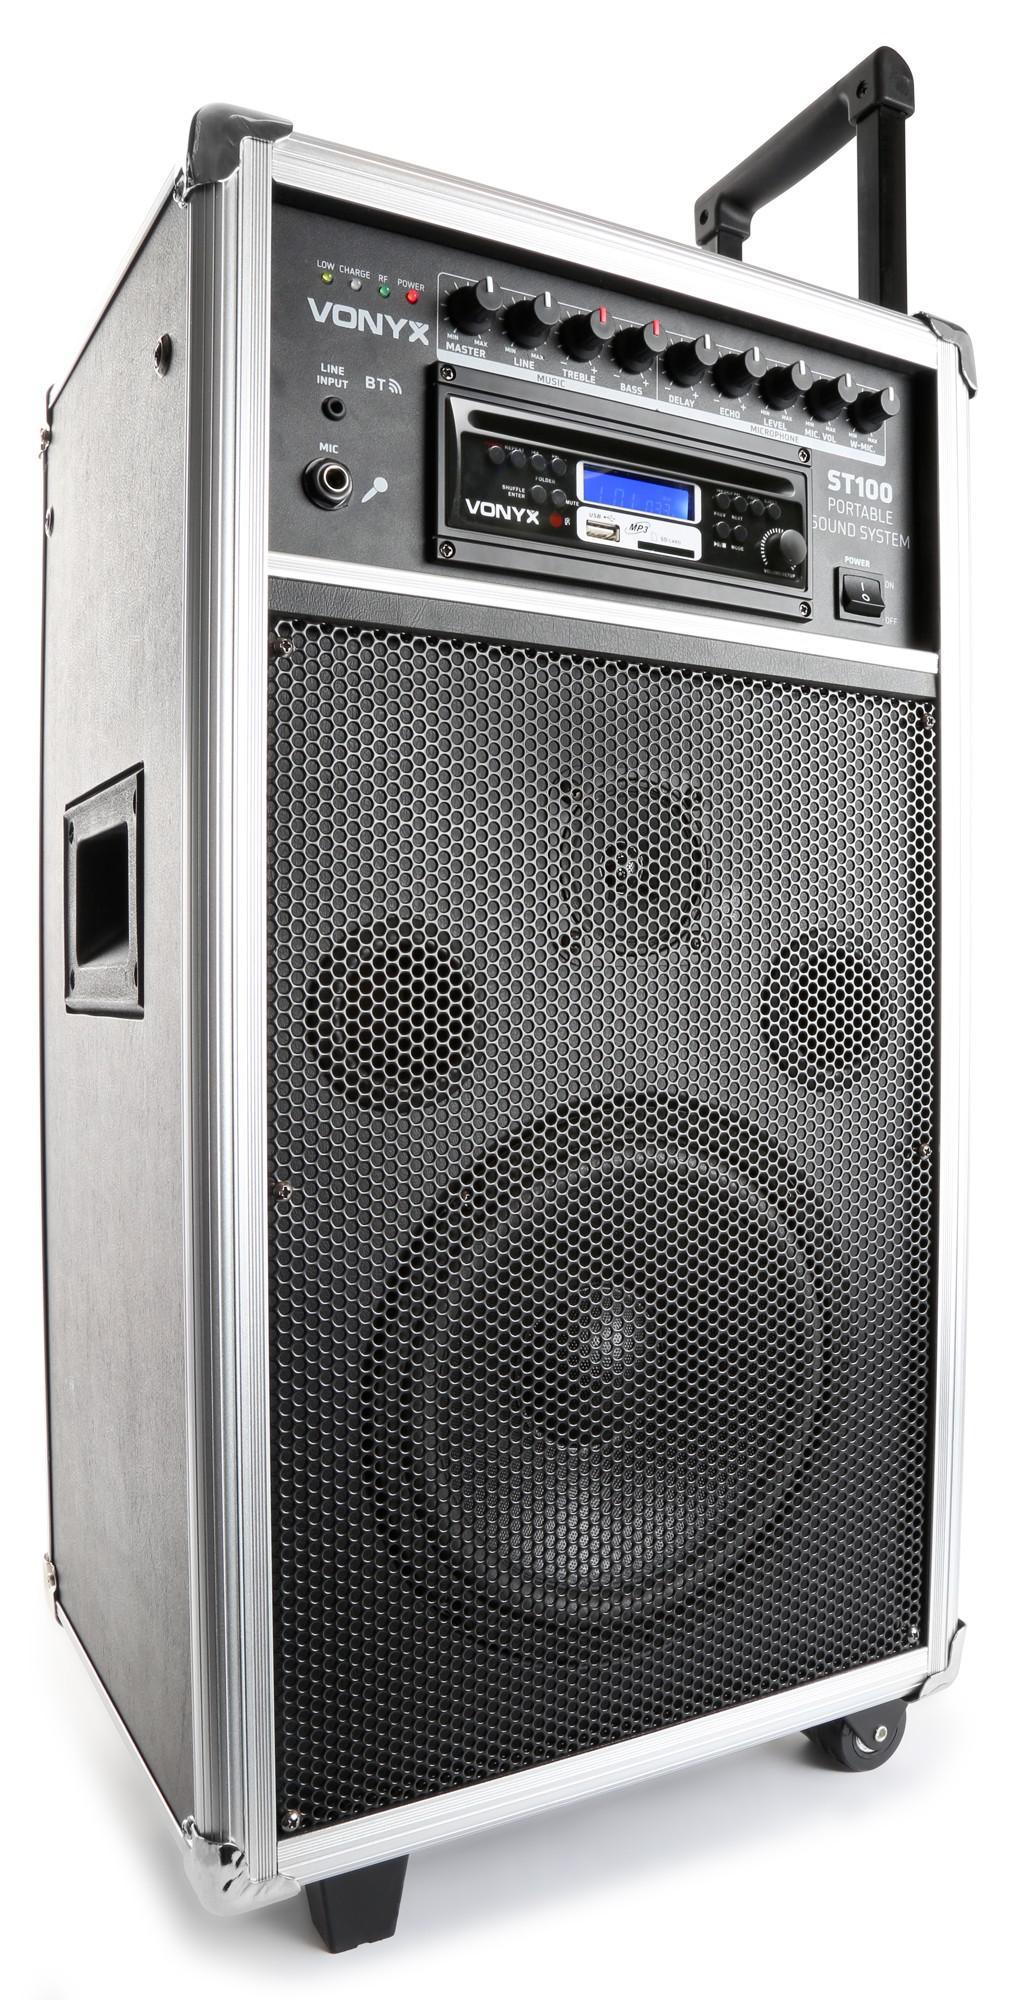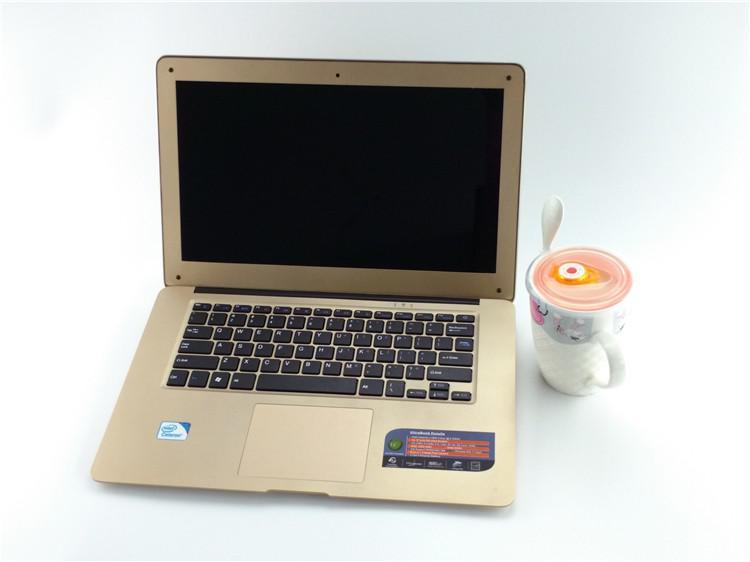The first image is the image on the left, the second image is the image on the right. Evaluate the accuracy of this statement regarding the images: "One image shows a laptop with a woman's face predominant on the screen.". Is it true? Answer yes or no. No. The first image is the image on the left, the second image is the image on the right. Given the left and right images, does the statement "An open gold-toned laptop computer is shown in one image." hold true? Answer yes or no. Yes. 